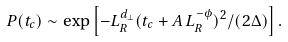Convert formula to latex. <formula><loc_0><loc_0><loc_500><loc_500>P ( t _ { c } ) \sim \exp \left [ - L _ { R } ^ { d _ { \bot } } ( t _ { c } + A \, L _ { R } ^ { - \phi } ) ^ { 2 } / ( 2 \Delta ) \right ] .</formula> 